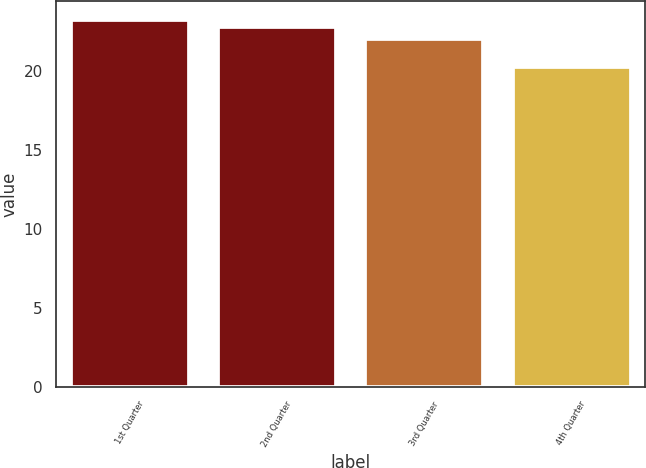Convert chart to OTSL. <chart><loc_0><loc_0><loc_500><loc_500><bar_chart><fcel>1st Quarter<fcel>2nd Quarter<fcel>3rd Quarter<fcel>4th Quarter<nl><fcel>23.24<fcel>22.78<fcel>22.02<fcel>20.21<nl></chart> 